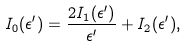Convert formula to latex. <formula><loc_0><loc_0><loc_500><loc_500>I _ { 0 } ( \epsilon ^ { \prime } ) = \frac { 2 I _ { 1 } ( \epsilon ^ { \prime } ) } { \epsilon ^ { \prime } } + I _ { 2 } ( \epsilon ^ { \prime } ) ,</formula> 